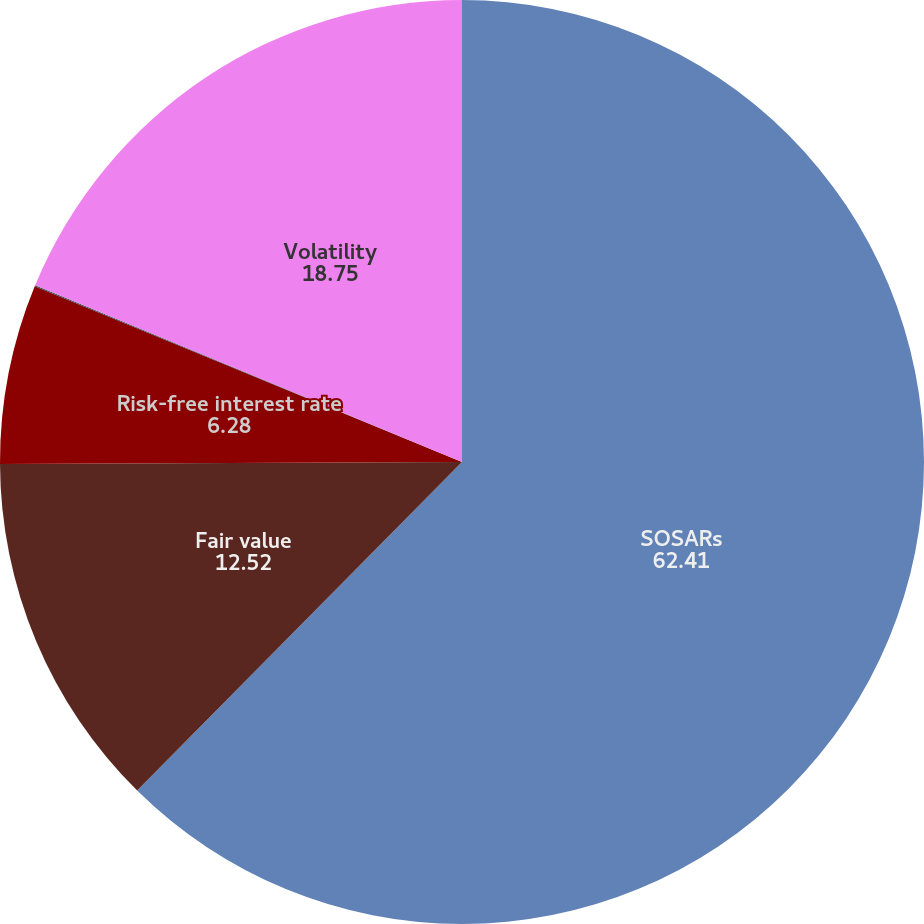Convert chart. <chart><loc_0><loc_0><loc_500><loc_500><pie_chart><fcel>SOSARs<fcel>Fair value<fcel>Risk-free interest rate<fcel>Dividend yield<fcel>Volatility<nl><fcel>62.41%<fcel>12.52%<fcel>6.28%<fcel>0.04%<fcel>18.75%<nl></chart> 